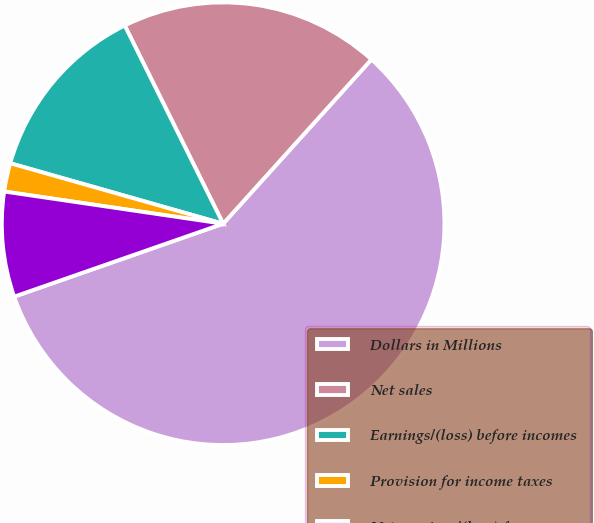<chart> <loc_0><loc_0><loc_500><loc_500><pie_chart><fcel>Dollars in Millions<fcel>Net sales<fcel>Earnings/(loss) before incomes<fcel>Provision for income taxes<fcel>Net earnings/(loss) from<nl><fcel>57.97%<fcel>19.02%<fcel>13.26%<fcel>2.08%<fcel>7.67%<nl></chart> 